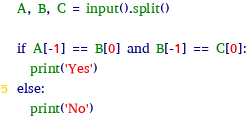<code> <loc_0><loc_0><loc_500><loc_500><_Python_>A, B, C = input().split()

if A[-1] == B[0] and B[-1] == C[0]:
  print('Yes')
else:
  print('No')</code> 